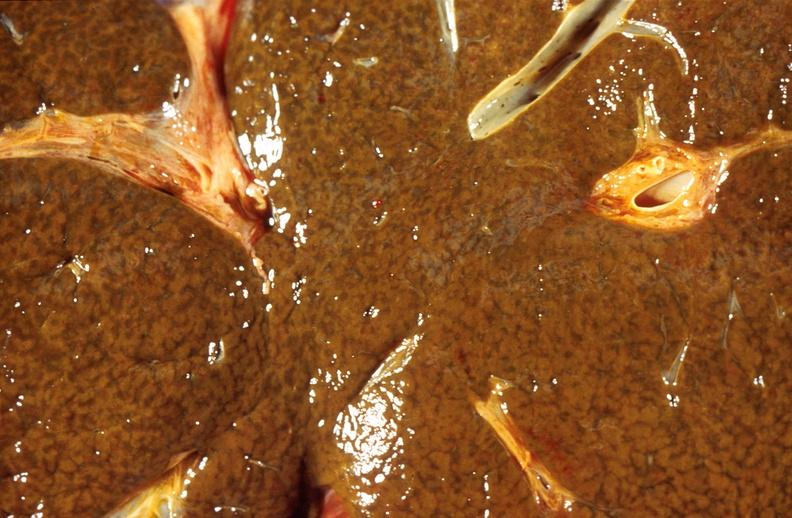what is present?
Answer the question using a single word or phrase. Hepatobiliary 